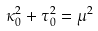Convert formula to latex. <formula><loc_0><loc_0><loc_500><loc_500>\kappa _ { 0 } ^ { 2 } + \tau _ { 0 } ^ { 2 } = \mu ^ { 2 }</formula> 